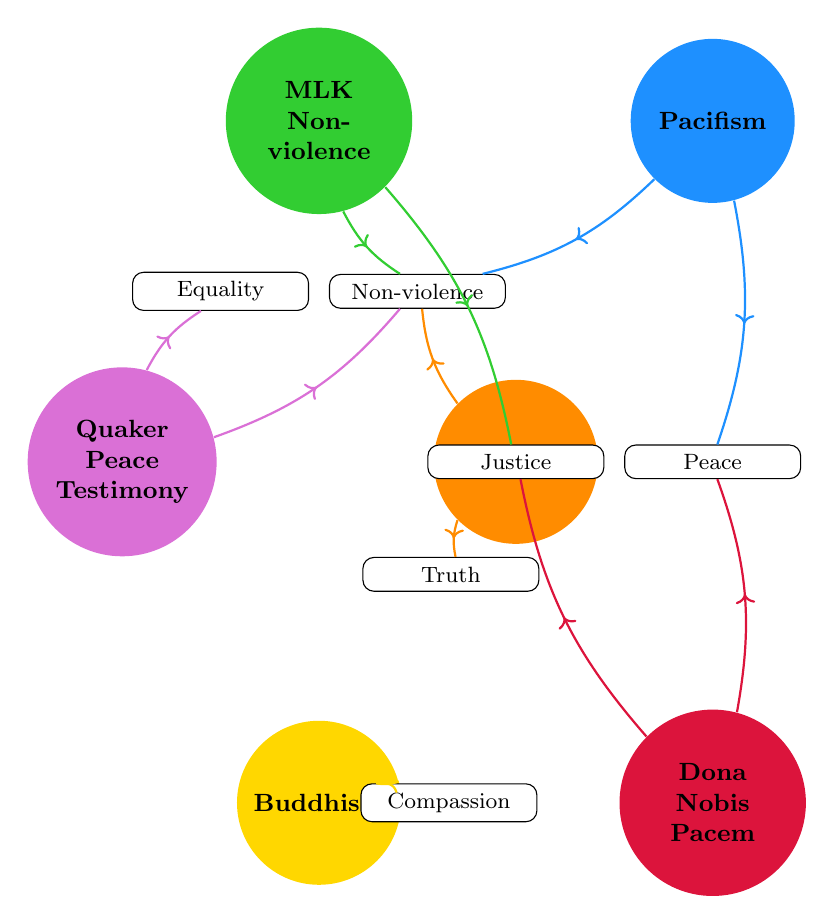What is the founder of Gandhism? The diagram indicates that Mahatma Gandhi is specified as the founder of Gandhism. This is shown in the node representing Gandhism, where the founder is explicitly stated.
Answer: Mahatma Gandhi How many key philosophies are associated with Buddhism? The diagram lists four key philosophies associated with Buddhism: Compassion, Mindfulness, Non-Attachment, and Peace. By examining the detailed listing under the Buddhism node, we see these four items are clearly defined.
Answer: 4 Which movement is directly linked to the philosophy of Non-violence? The diagram shows multiple movements connected to Non-violence. Specifically, these movements include Gandhism, MLK Non-violence, Pacifism, and Quaker Peace Testimony, all illustrated by arrows linking to the Non-violence node.
Answer: Gandhism, MLK Non-violence, Pacifism, Quaker Peace Testimony What is one of the key philosophies shared by the Quaker Peace Testimony and MLK Non-violence? By analyzing the connections between nodes, we can see that both Quaker Peace Testimony and MLK Non-violence are linked to the philosophy of Equality. This can be confirmed by tracing their connections to the Equality node in the diagram.
Answer: Equality Which philosophy is connected to the Dona Nobis Pacem movement? The diagram indicates that the Dona Nobis Pacem movement is directly connected to the philosophy of Peace, as represented by an arrow leading from the Dona Nobis Pacem node to the Peace node.
Answer: Peace How many movements are associated with the concept of Justice? The diagram shows that Justice is a key philosophy related to two movements: MLK Non-violence and Dona Nobis Pacem, with arrows depicting these relationships leading to the Justice node. Thus, we find two movements associated with this philosophy.
Answer: 2 What philosophy does Buddhism emphasize that is not directly listed under Gandhism? The philosophy of Mindfulness is highlighted under Buddhism but is not mentioned under Gandhism. By examining the philosophies listed under each movement, we can identify this distinct philosophy connected uniquely to Buddhism.
Answer: Mindfulness Which two movements share the philosophy of Peace? The movements Pacifism and Dona Nobis Pacem share the philosophy of Peace, as shown by the direct connections from their respective nodes to the Peace node in the diagram, indicating their shared value of promoting peace.
Answer: Pacifism, Dona Nobis Pacem 